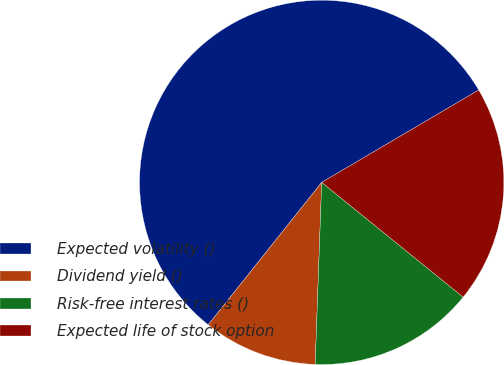Convert chart. <chart><loc_0><loc_0><loc_500><loc_500><pie_chart><fcel>Expected volatility ()<fcel>Dividend yield ()<fcel>Risk-free interest rates ()<fcel>Expected life of stock option<nl><fcel>55.83%<fcel>10.14%<fcel>14.72%<fcel>19.31%<nl></chart> 